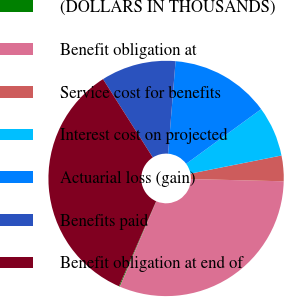Convert chart to OTSL. <chart><loc_0><loc_0><loc_500><loc_500><pie_chart><fcel>(DOLLARS IN THOUSANDS)<fcel>Benefit obligation at<fcel>Service cost for benefits<fcel>Interest cost on projected<fcel>Actuarial loss (gain)<fcel>Benefits paid<fcel>Benefit obligation at end of<nl><fcel>0.12%<fcel>31.05%<fcel>3.51%<fcel>6.9%<fcel>13.69%<fcel>10.29%<fcel>34.44%<nl></chart> 